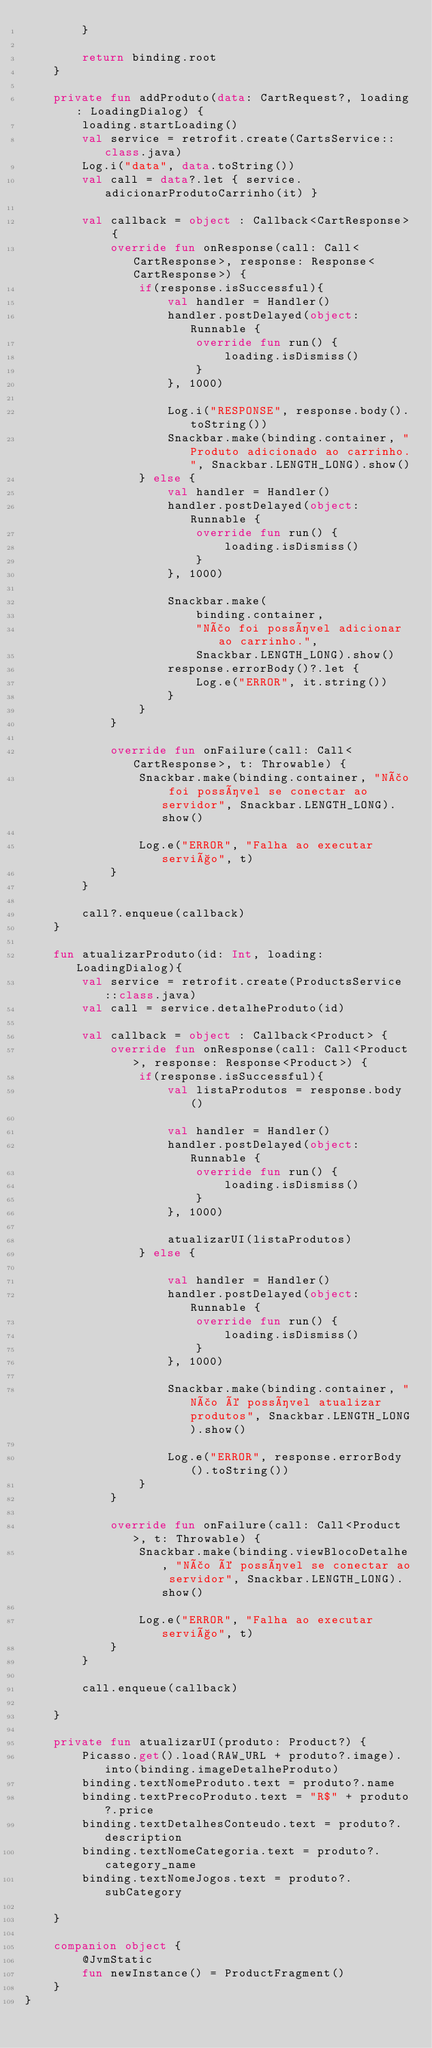<code> <loc_0><loc_0><loc_500><loc_500><_Kotlin_>        }

        return binding.root
    }

    private fun addProduto(data: CartRequest?, loading: LoadingDialog) {
        loading.startLoading()
        val service = retrofit.create(CartsService::class.java)
        Log.i("data", data.toString())
        val call = data?.let { service.adicionarProdutoCarrinho(it) }

        val callback = object : Callback<CartResponse> {
            override fun onResponse(call: Call<CartResponse>, response: Response<CartResponse>) {
                if(response.isSuccessful){
                    val handler = Handler()
                    handler.postDelayed(object: Runnable {
                        override fun run() {
                            loading.isDismiss()
                        }
                    }, 1000)

                    Log.i("RESPONSE", response.body().toString())
                    Snackbar.make(binding.container, "Produto adicionado ao carrinho.", Snackbar.LENGTH_LONG).show()
                } else {
                    val handler = Handler()
                    handler.postDelayed(object: Runnable {
                        override fun run() {
                            loading.isDismiss()
                        }
                    }, 1000)

                    Snackbar.make(
                        binding.container,
                        "Não foi possível adicionar ao carrinho.",
                        Snackbar.LENGTH_LONG).show()
                    response.errorBody()?.let {
                        Log.e("ERROR", it.string())
                    }
                }
            }

            override fun onFailure(call: Call<CartResponse>, t: Throwable) {
                Snackbar.make(binding.container, "Não foi possível se conectar ao servidor", Snackbar.LENGTH_LONG).show()

                Log.e("ERROR", "Falha ao executar serviço", t)
            }
        }

        call?.enqueue(callback)
    }

    fun atualizarProduto(id: Int, loading: LoadingDialog){
        val service = retrofit.create(ProductsService::class.java)
        val call = service.detalheProduto(id)

        val callback = object : Callback<Product> {
            override fun onResponse(call: Call<Product>, response: Response<Product>) {
                if(response.isSuccessful){
                    val listaProdutos = response.body()

                    val handler = Handler()
                    handler.postDelayed(object: Runnable {
                        override fun run() {
                            loading.isDismiss()
                        }
                    }, 1000)

                    atualizarUI(listaProdutos)
                } else {

                    val handler = Handler()
                    handler.postDelayed(object: Runnable {
                        override fun run() {
                            loading.isDismiss()
                        }
                    }, 1000)

                    Snackbar.make(binding.container, "Não é possível atualizar produtos", Snackbar.LENGTH_LONG).show()

                    Log.e("ERROR", response.errorBody().toString())
                }
            }

            override fun onFailure(call: Call<Product>, t: Throwable) {
                Snackbar.make(binding.viewBlocoDetalhe, "Não é possível se conectar ao servidor", Snackbar.LENGTH_LONG).show()

                Log.e("ERROR", "Falha ao executar serviço", t)
            }
        }

        call.enqueue(callback)

    }

    private fun atualizarUI(produto: Product?) {
        Picasso.get().load(RAW_URL + produto?.image).into(binding.imageDetalheProduto)
        binding.textNomeProduto.text = produto?.name
        binding.textPrecoProduto.text = "R$" + produto?.price
        binding.textDetalhesConteudo.text = produto?.description
        binding.textNomeCategoria.text = produto?.category_name
        binding.textNomeJogos.text = produto?.subCategory

    }

    companion object {
        @JvmStatic
        fun newInstance() = ProductFragment()
    }
}</code> 